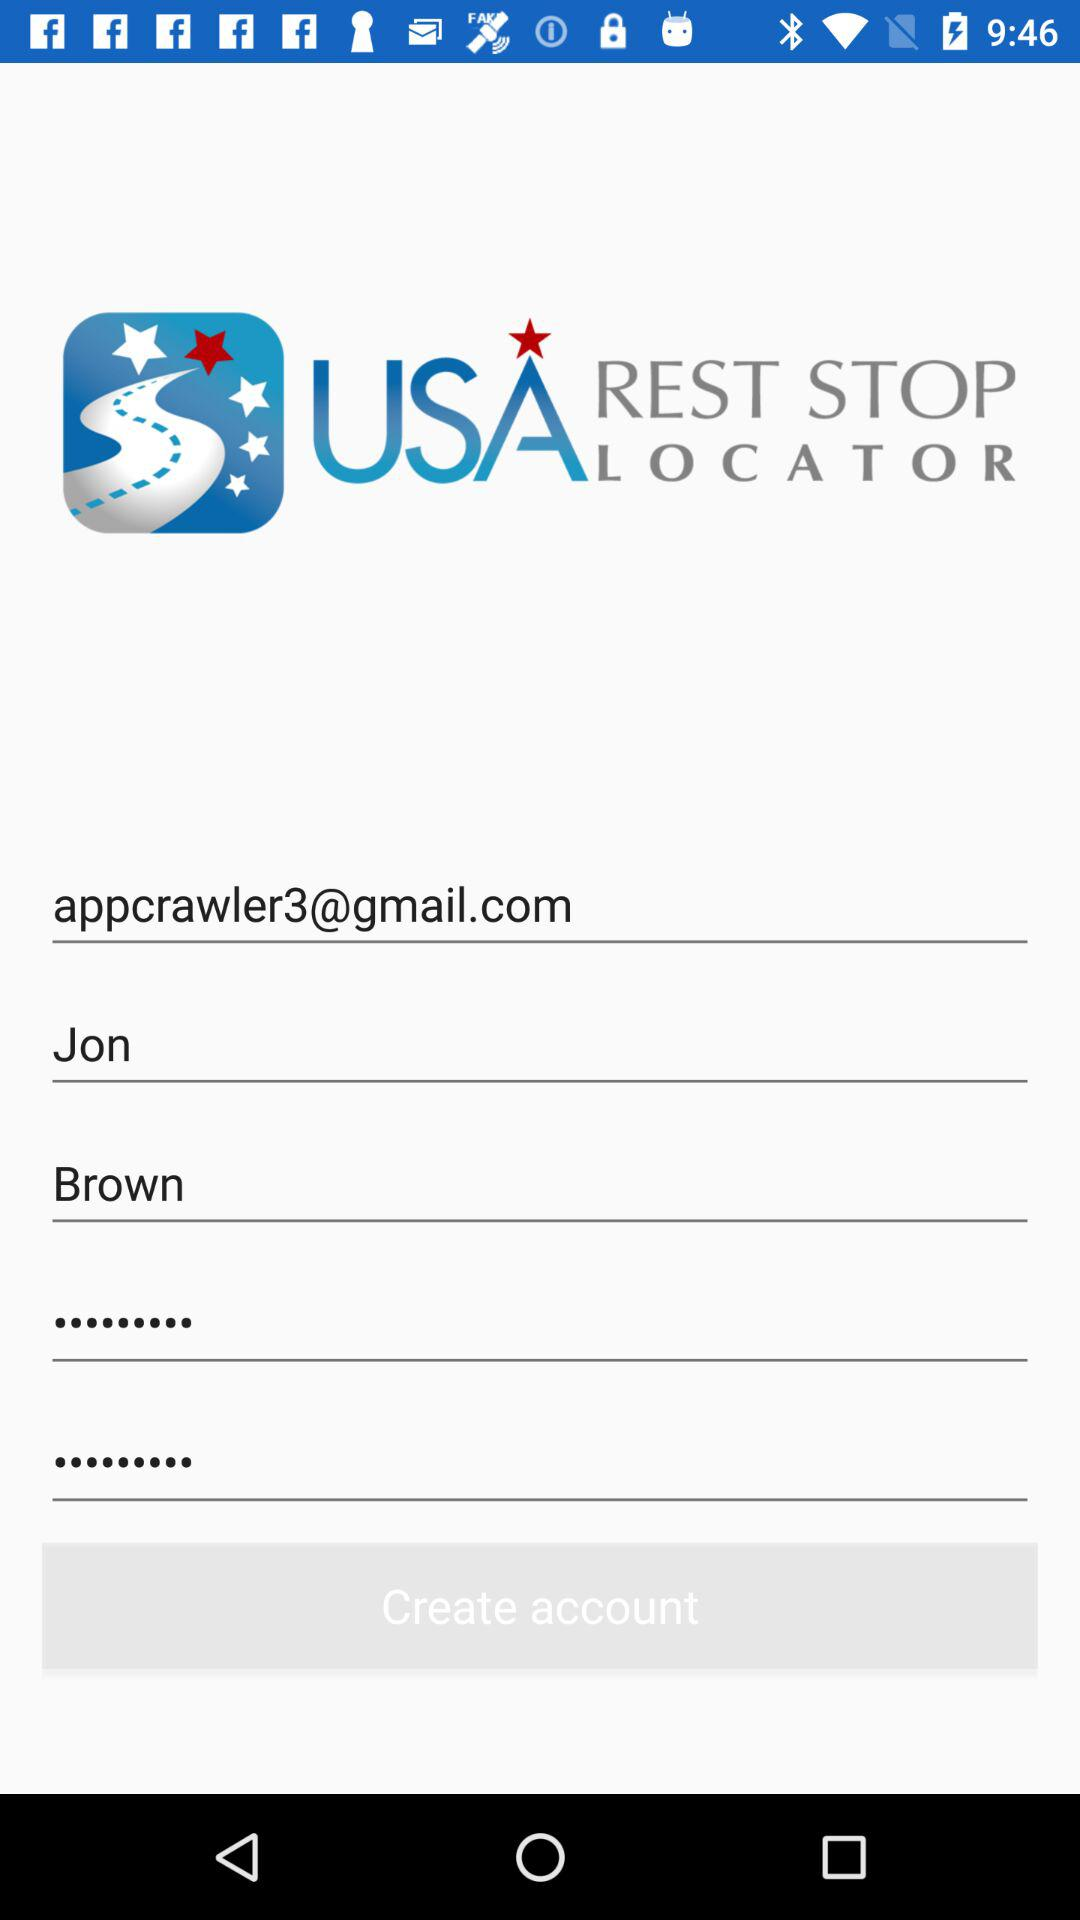What is the application name? The application name is "USA Rest Stop Locator". 